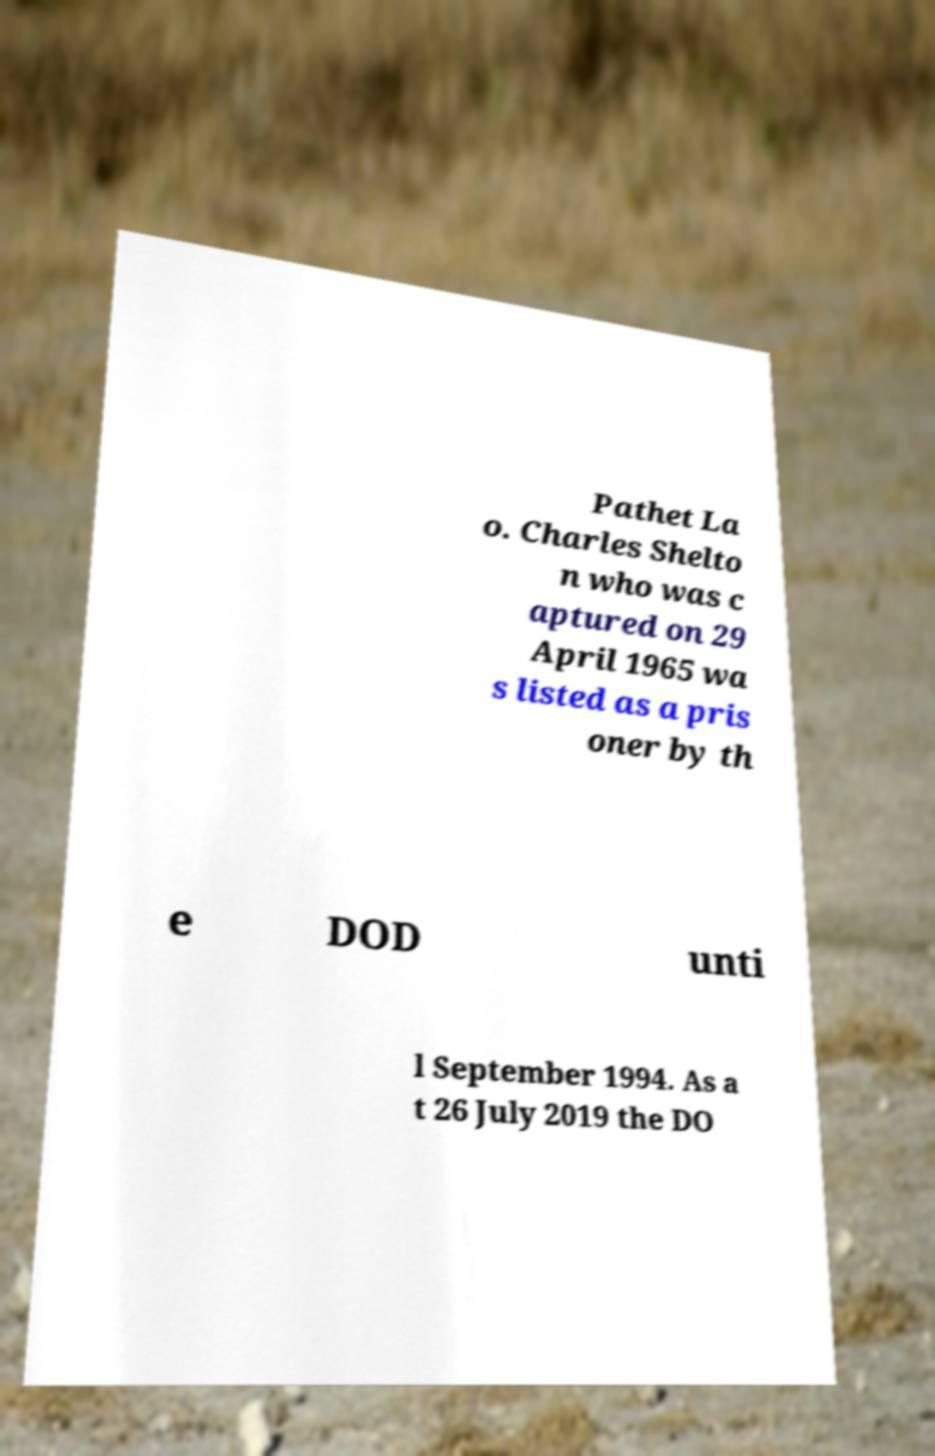Can you accurately transcribe the text from the provided image for me? Pathet La o. Charles Shelto n who was c aptured on 29 April 1965 wa s listed as a pris oner by th e DOD unti l September 1994. As a t 26 July 2019 the DO 